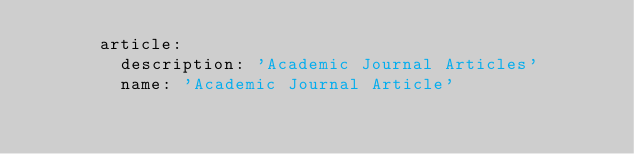Convert code to text. <code><loc_0><loc_0><loc_500><loc_500><_YAML_>      article:
        description: 'Academic Journal Articles'
        name: 'Academic Journal Article'
</code> 